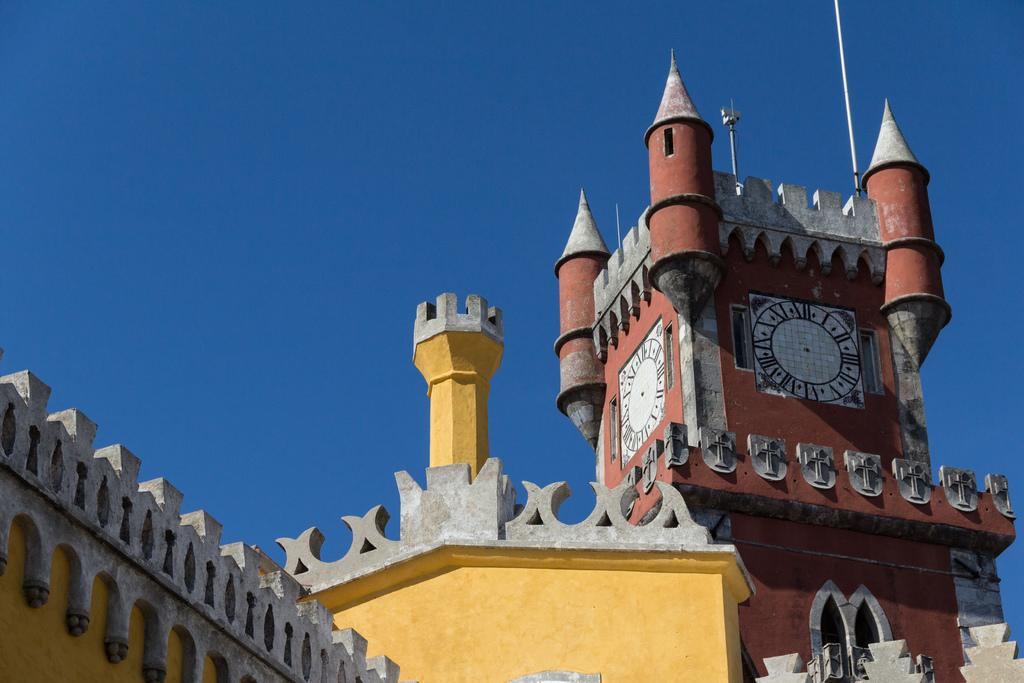What is the color of the sky in the image? The sky is blue in the image. What type of structure can be seen in the image? There is a building in the image. What specific feature is present on the building? There is a clock tower in the image. How many clocks are visible on the clock tower? Clocks are present on the clock tower. What type of rice is being cooked in the image? There is no rice present in the image. How many army personnel can be seen in the image? There are no army personnel present in the image. 